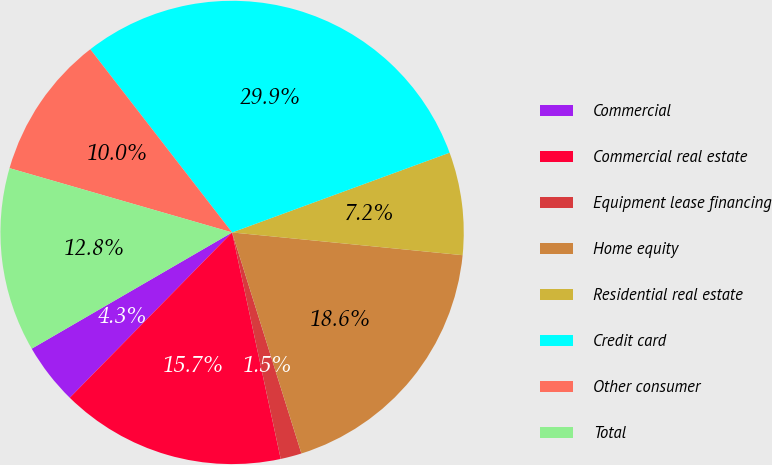Convert chart to OTSL. <chart><loc_0><loc_0><loc_500><loc_500><pie_chart><fcel>Commercial<fcel>Commercial real estate<fcel>Equipment lease financing<fcel>Home equity<fcel>Residential real estate<fcel>Credit card<fcel>Other consumer<fcel>Total<nl><fcel>4.28%<fcel>15.72%<fcel>1.47%<fcel>18.6%<fcel>7.16%<fcel>29.89%<fcel>10.04%<fcel>12.84%<nl></chart> 